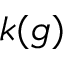Convert formula to latex. <formula><loc_0><loc_0><loc_500><loc_500>k ( g )</formula> 